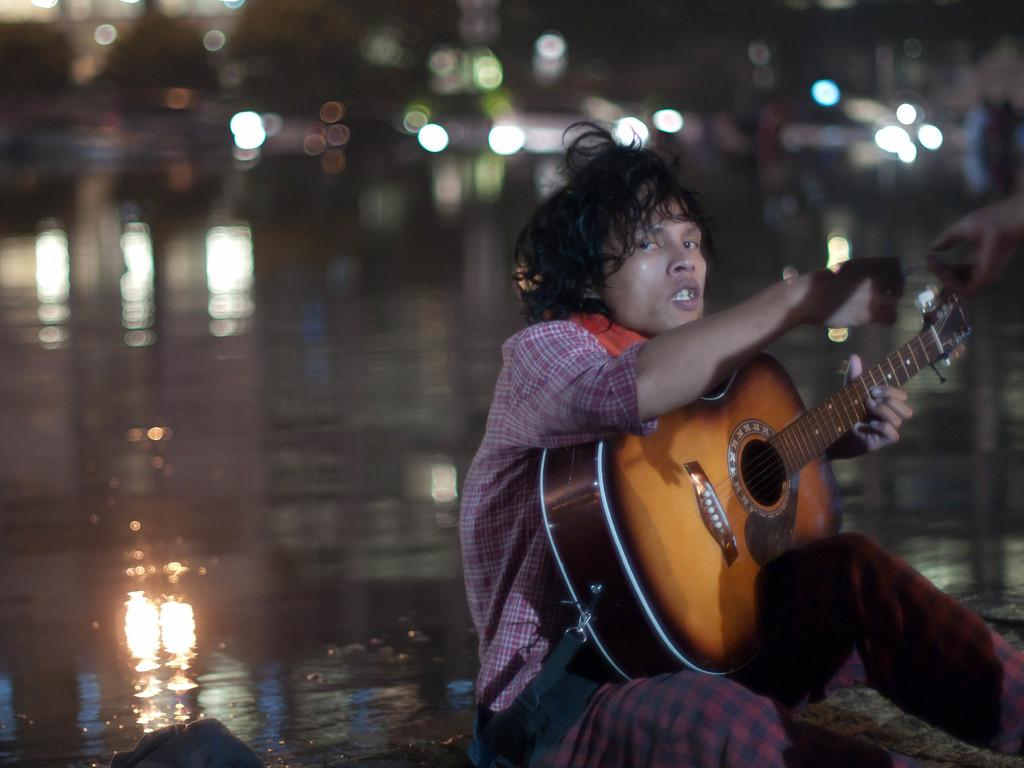What is the man in the image holding? The man is holding a guitar. Where is the man sitting in the image? The man is sitting on a path. Whose hand is visible in the image? Another person's hand is visible in the image. What can be seen in the background of the image? There is water visible in the background of the image. What type of jelly is being used to create the music in the image? There is no jelly present in the image, and music is not being created with jelly. 